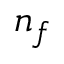<formula> <loc_0><loc_0><loc_500><loc_500>n _ { f }</formula> 